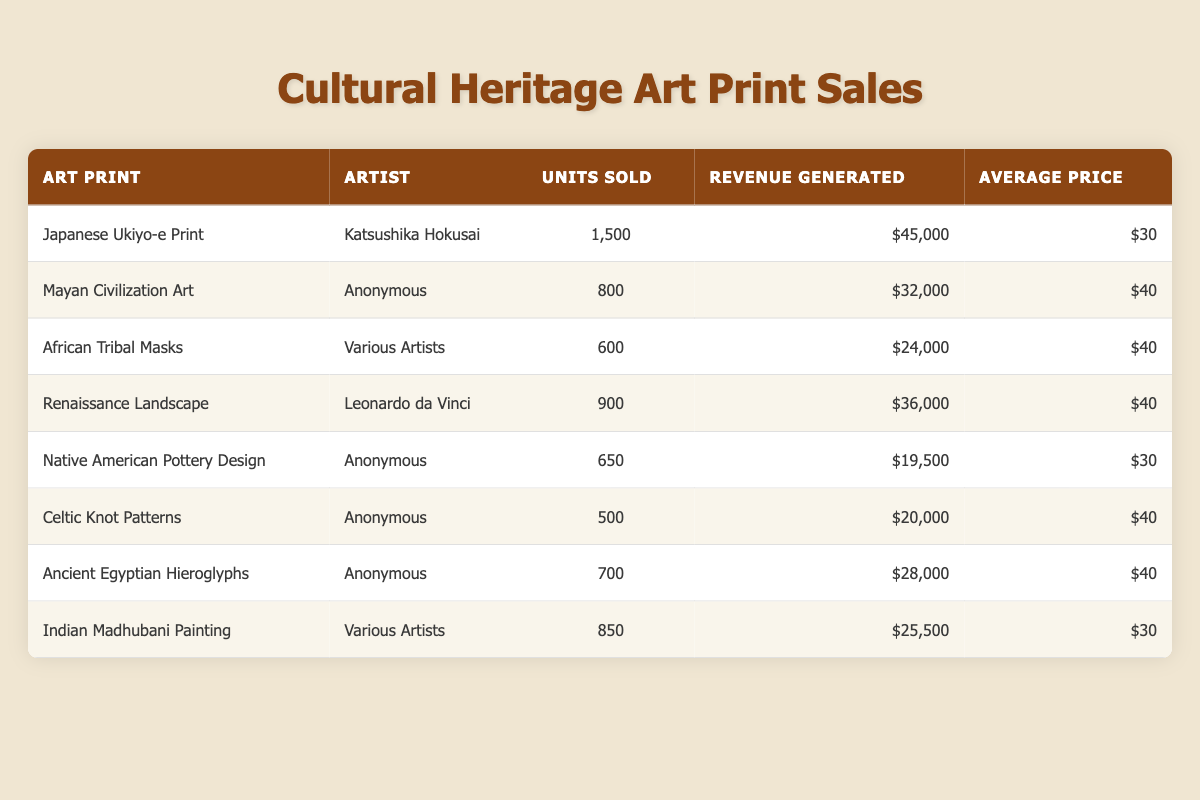What is the highest revenue generated by an art print? By examining the revenue generated for each art print, the Japanese Ukiyo-e Print by Katsushika Hokusai has the highest revenue of $45,000.
Answer: $45,000 How many units of the Mayan Civilization Art were sold? The table directly shows that 800 units of the Mayan Civilization Art were sold.
Answer: 800 What is the average price of all the art prints listed in the table? To find the average price, we sum the average prices of all art prints: $30 + $40 + $40 + $40 + $30 + $40 + $40 + $30 = $280. Then divide by the number of art prints (8): $280 / 8 = $35.
Answer: $35 Which artist sold the most units in the holiday season? The Japanese Ukiyo-e Print sold the most units at 1,500, making Katsushika Hokusai the artist with the highest units sold.
Answer: Katsushika Hokusai Is the revenue generated by African Tribal Masks greater than that of Native American Pottery Design? The African Tribal Masks generated $24,000, whereas the Native American Pottery Design generated $19,500. Since $24,000 is greater than $19,500, the statement is true.
Answer: Yes What is the total revenue generated by the Renaissance Landscape and Indian Madhubani Painting combined? The Renaissance Landscape generated $36,000 and the Indian Madhubani Painting generated $25,500. Adding these gives $36,000 + $25,500 = $61,500.
Answer: $61,500 Which art print had the lowest units sold, and how many were sold? The Celtic Knot Patterns had the lowest units sold, with a total of 500.
Answer: Celtic Knot Patterns, 500 If the total units sold for all art prints is calculated, what would that number be? Adding the units sold: 1500 + 800 + 600 + 900 + 650 + 500 + 700 + 850 gives 5,500 total units sold.
Answer: 5,500 Did any anonymous artist produce more than 700 units sold? The Native American Pottery Design sold 650 units and the Celtic Knot Patterns sold 500 units, which are both less than 700. Therefore, none of the anonymous artists produced more than 700 units sold.
Answer: No What percentage of the total revenue does the Japanese Ukiyo-e Print contribute? The total revenue from all prints is $45,000 + $32,000 + $24,000 + $36,000 + $19,500 + $20,000 + $28,000 + $25,500 = $ 230,000. The percentage contribution of the Japanese Ukiyo-e Print = ($45,000 / $230,000) * 100 ≈ 19.57%.
Answer: 19.57% 